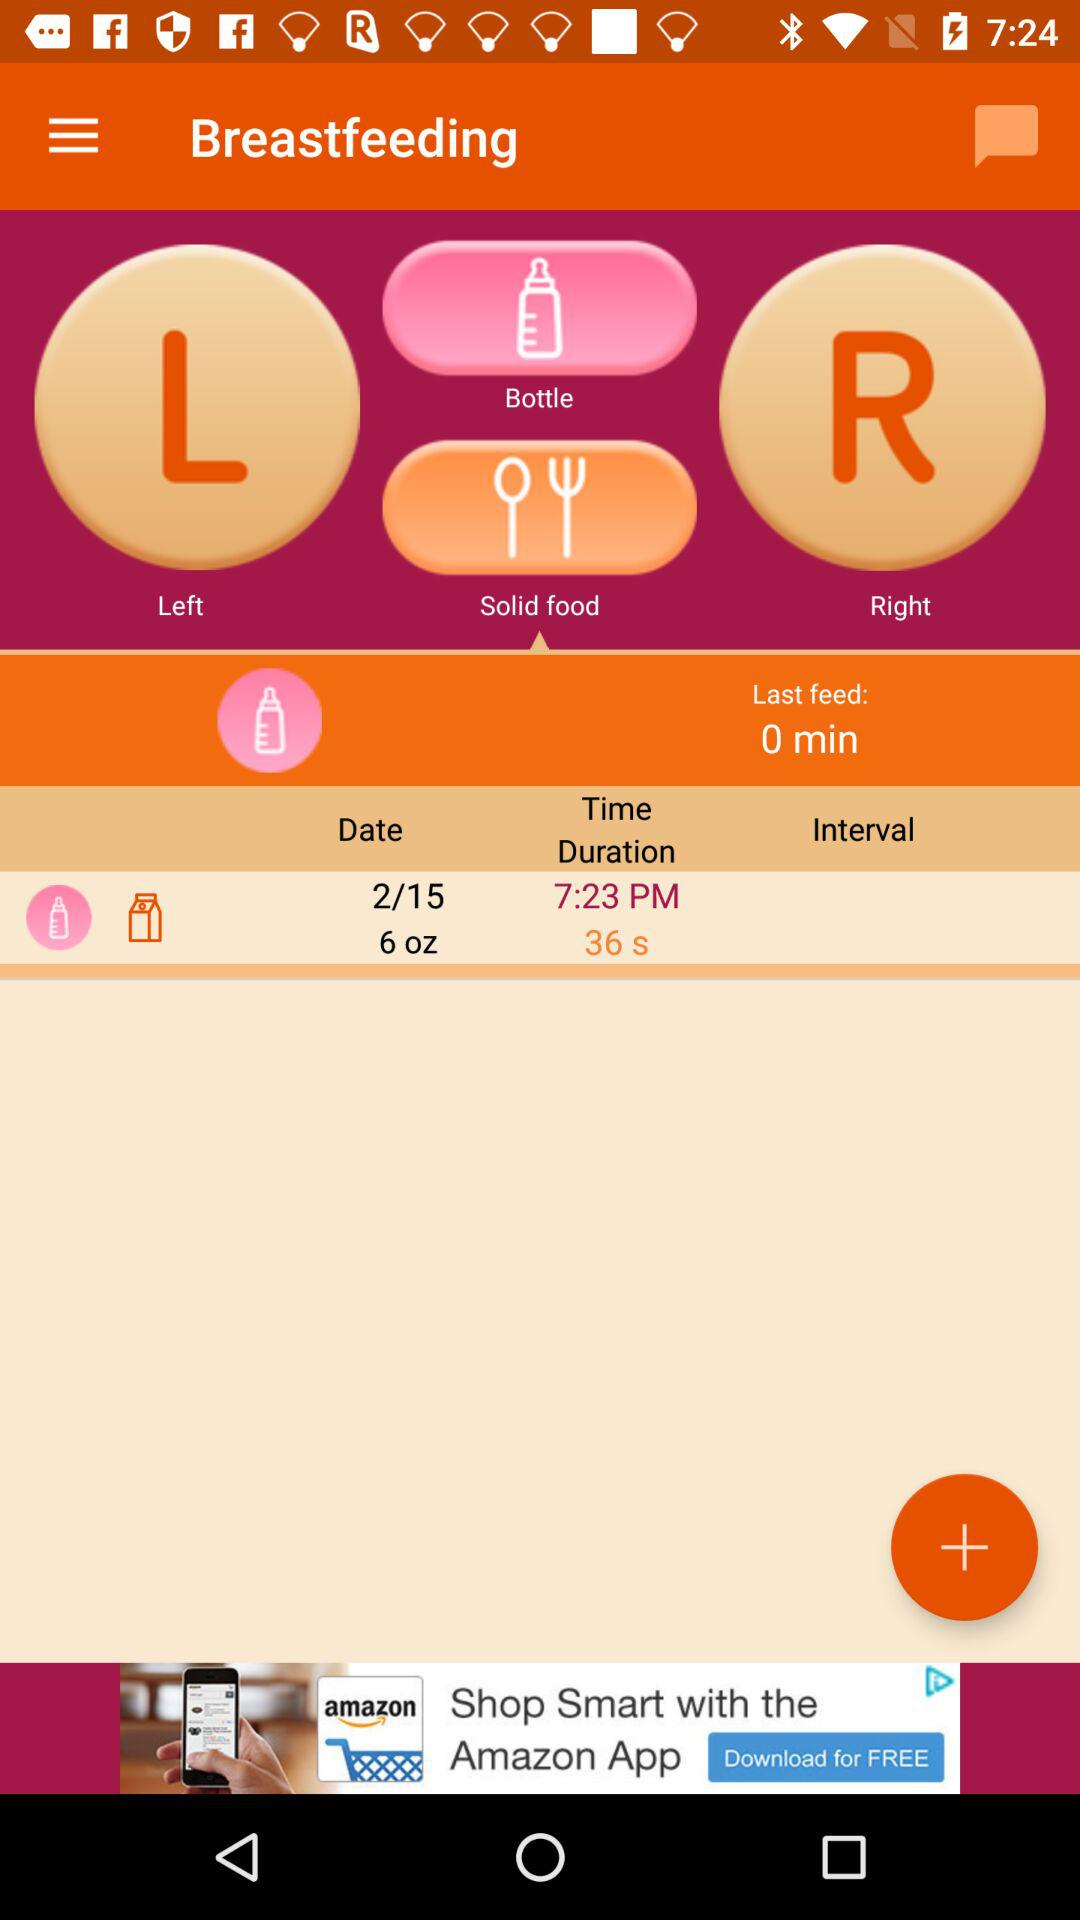When was the last feed done? The last feed was done 0 minutes ago. 